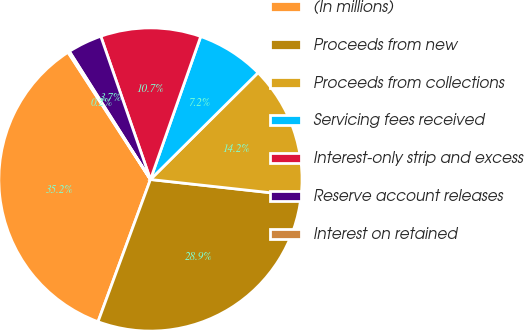Convert chart. <chart><loc_0><loc_0><loc_500><loc_500><pie_chart><fcel>(In millions)<fcel>Proceeds from new<fcel>Proceeds from collections<fcel>Servicing fees received<fcel>Interest-only strip and excess<fcel>Reserve account releases<fcel>Interest on retained<nl><fcel>35.23%<fcel>28.87%<fcel>14.19%<fcel>7.18%<fcel>10.69%<fcel>3.67%<fcel>0.17%<nl></chart> 